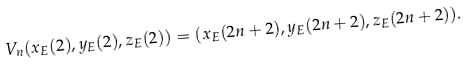<formula> <loc_0><loc_0><loc_500><loc_500>V _ { n } ( x _ { E } ( 2 ) , y _ { E } ( 2 ) , z _ { E } ( 2 ) ) = ( x _ { E } ( 2 n + 2 ) , y _ { E } ( 2 n + 2 ) , z _ { E } ( 2 n + 2 ) ) .</formula> 